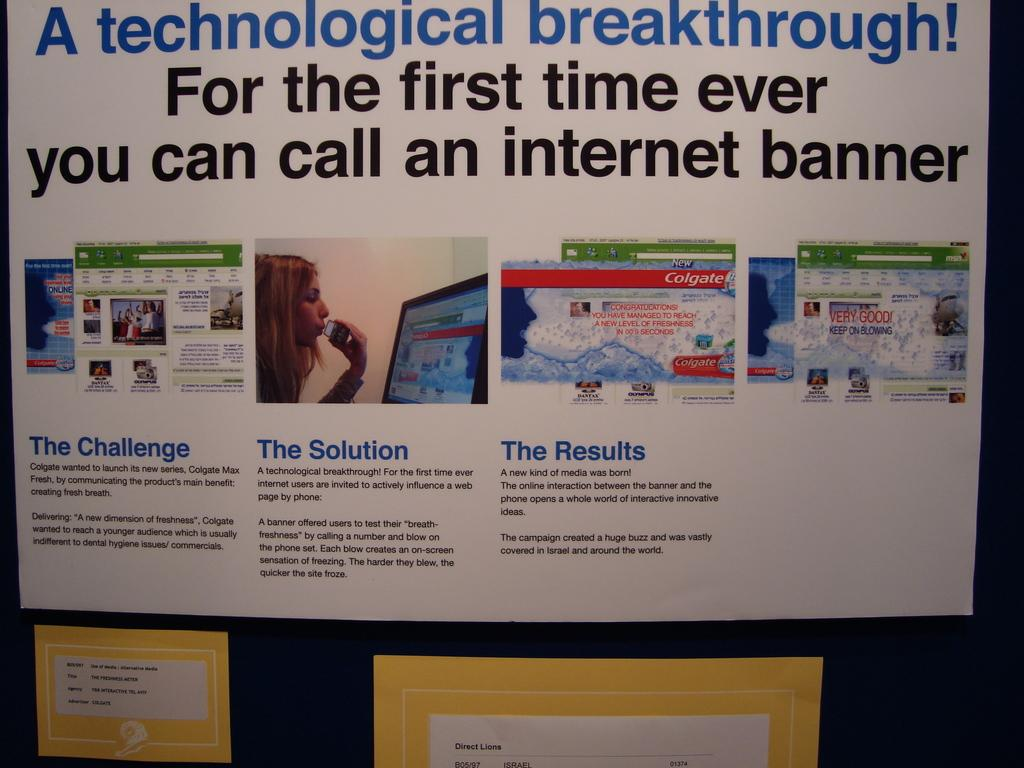Provide a one-sentence caption for the provided image. A poster titled A technological breakthrough! For the first time ever you can call and Internet banner. 